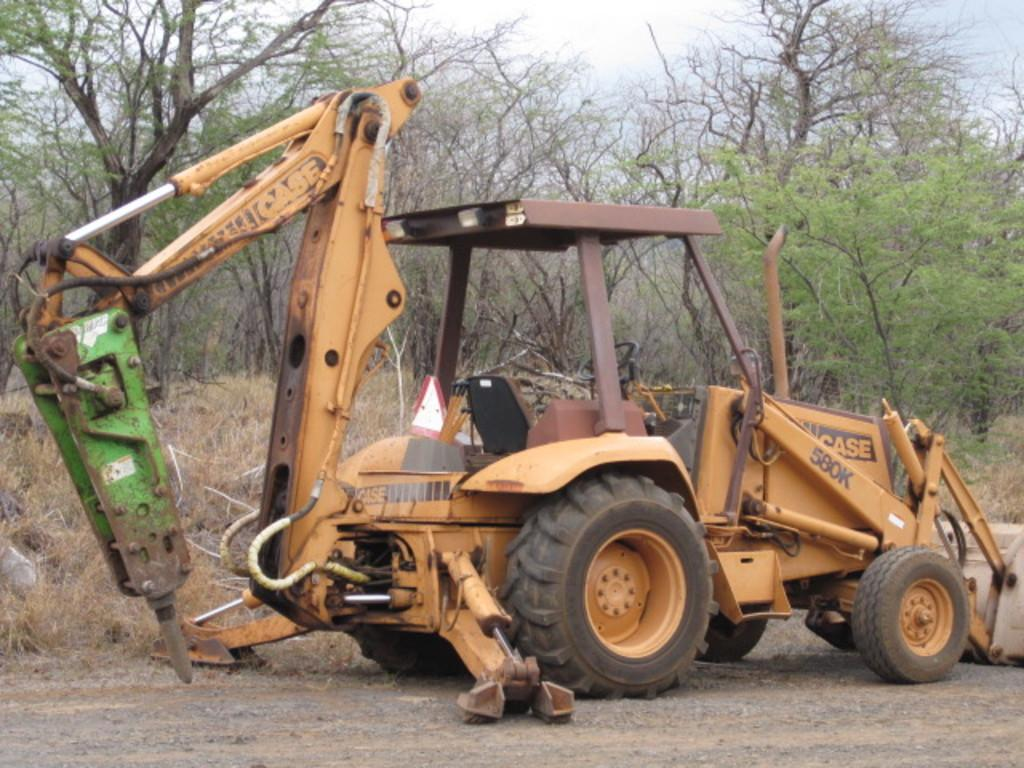What is the main subject of the image? There is a vehicle in the image. Where is the vehicle located? The vehicle is parked on the ground. What can be seen in the background of the image? There are plants and a group of trees visible in the background of the image. What is visible at the top of the image? The sky is visible at the top of the image. What is the aftermath of the collision between the vehicle and the building in the image? There is no building or collision present in the image; it only features a vehicle parked on the ground with plants, trees, and the sky visible in the background. 